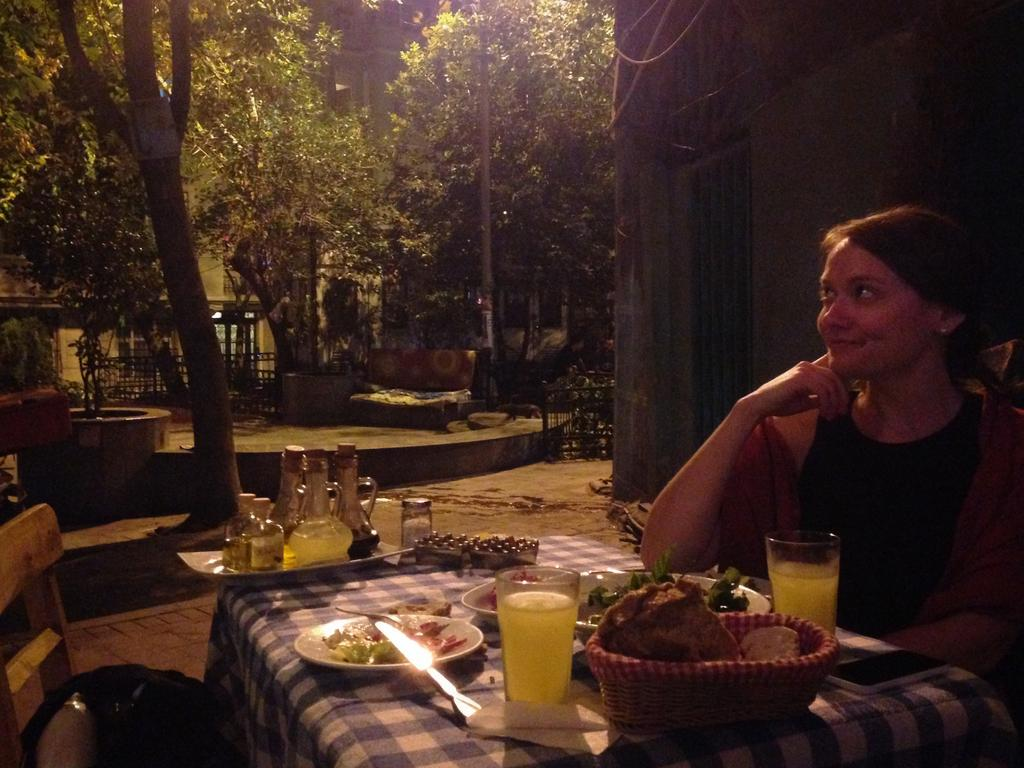What is the woman in the image doing? The woman is sitting on a chair in the image. What is the woman holding in the image? The woman is holding juice glasses in the image. What else can be seen on the table or surface in the image? There are plates in the image. What is visible on the left side of the image? There is a tree on the left side of the image. What type of structure is visible in the image? There is a building in the image. What is the condition of the woman's balance in the image? There is no information provided about the woman's balance in the image, so it cannot be determined. 